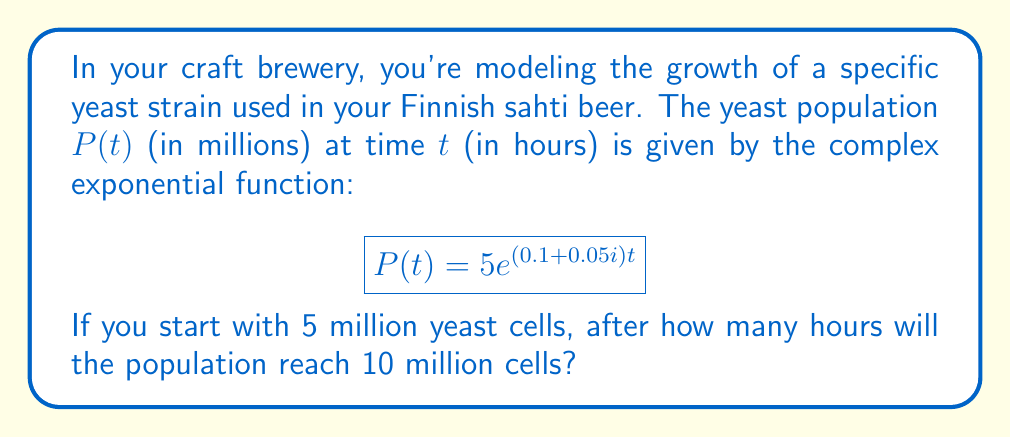Give your solution to this math problem. Let's approach this step-by-step:

1) We need to find $t$ when $P(t) = 10$ million cells.

2) Set up the equation:
   $$10 = 5e^{(0.1+0.05i)t}$$

3) Divide both sides by 5:
   $$2 = e^{(0.1+0.05i)t}$$

4) Take the natural logarithm of both sides:
   $$\ln(2) = (0.1+0.05i)t$$

5) Divide both sides by $(0.1+0.05i)$:
   $$t = \frac{\ln(2)}{0.1+0.05i}$$

6) To divide by a complex number, multiply numerator and denominator by the complex conjugate:
   $$t = \frac{\ln(2)}{0.1+0.05i} \cdot \frac{0.1-0.05i}{0.1-0.05i}$$

7) Simplify:
   $$t = \frac{\ln(2)(0.1-0.05i)}{0.1^2+0.05^2} = \frac{\ln(2)(0.1-0.05i)}{0.0125}$$

8) Calculate:
   $$t \approx 5.545 - 2.772i$$

9) The imaginary part represents oscillations in the population. We're interested in the real part, which represents the overall growth trend.
Answer: Approximately 5.55 hours 